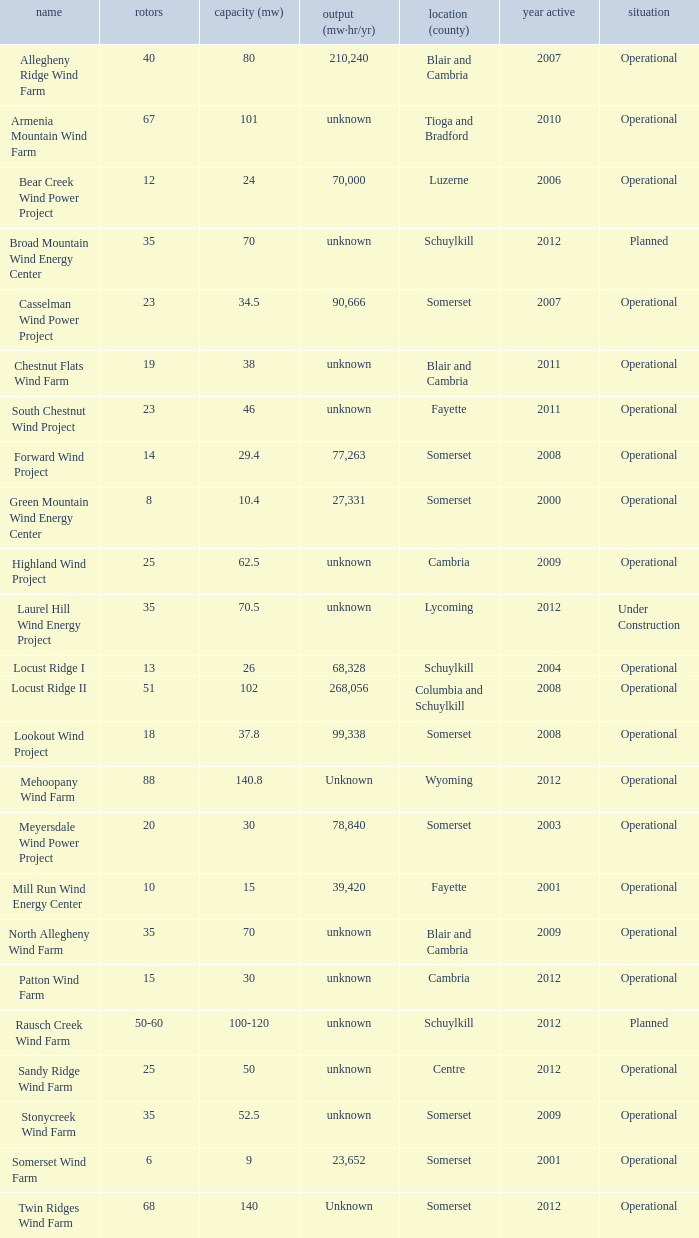What year was Fayette operational at 46? 2011.0. 